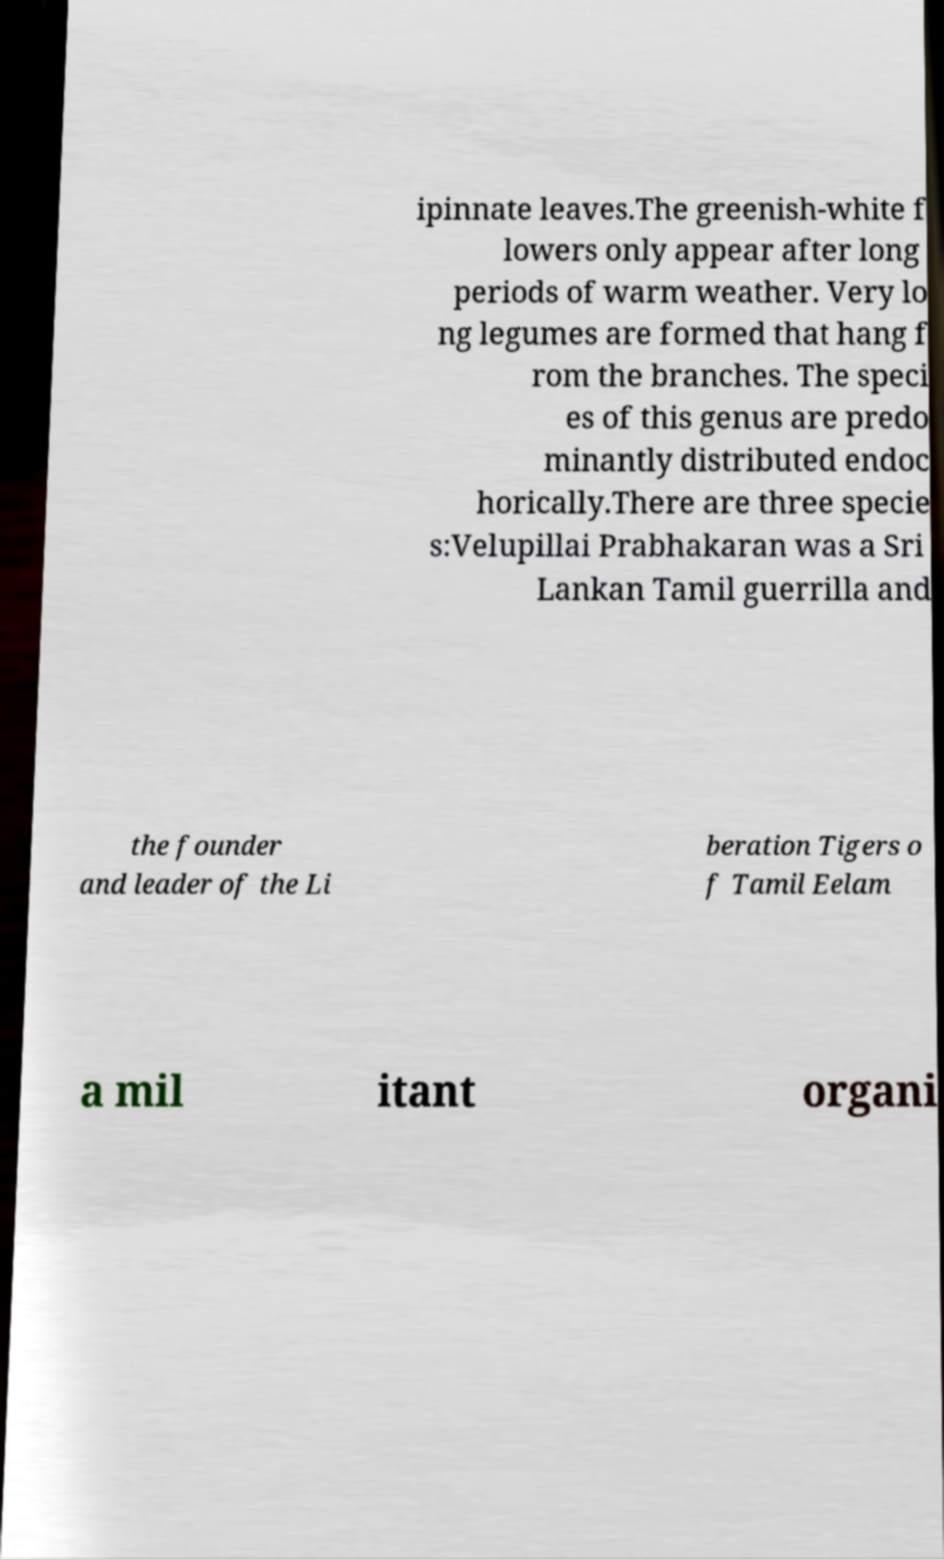I need the written content from this picture converted into text. Can you do that? ipinnate leaves.The greenish-white f lowers only appear after long periods of warm weather. Very lo ng legumes are formed that hang f rom the branches. The speci es of this genus are predo minantly distributed endoc horically.There are three specie s:Velupillai Prabhakaran was a Sri Lankan Tamil guerrilla and the founder and leader of the Li beration Tigers o f Tamil Eelam a mil itant organi 